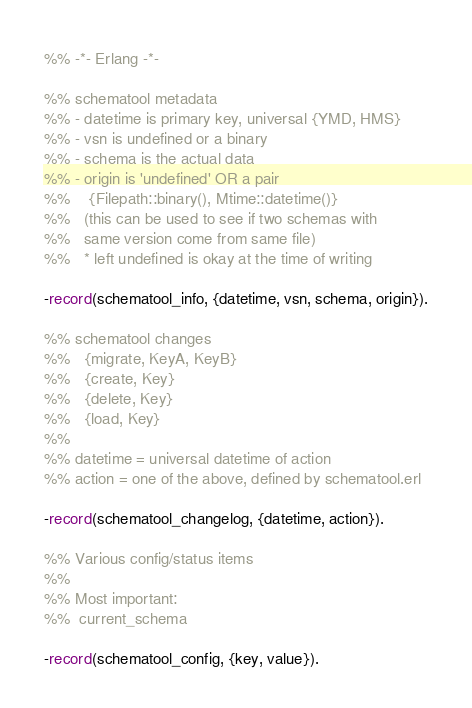Convert code to text. <code><loc_0><loc_0><loc_500><loc_500><_Erlang_>%% -*- Erlang -*-

%% schematool metadata
%% - datetime is primary key, universal {YMD, HMS}
%% - vsn is undefined or a binary
%% - schema is the actual data
%% - origin is 'undefined' OR a pair
%%    {Filepath::binary(), Mtime::datetime()}
%%   (this can be used to see if two schemas with
%%   same version come from same file)
%%   * left undefined is okay at the time of writing

-record(schematool_info, {datetime, vsn, schema, origin}).

%% schematool changes
%%   {migrate, KeyA, KeyB}
%%   {create, Key}
%%   {delete, Key}
%%   {load, Key}
%%
%% datetime = universal datetime of action
%% action = one of the above, defined by schematool.erl

-record(schematool_changelog, {datetime, action}).

%% Various config/status items
%%
%% Most important:
%%  current_schema

-record(schematool_config, {key, value}).
</code> 